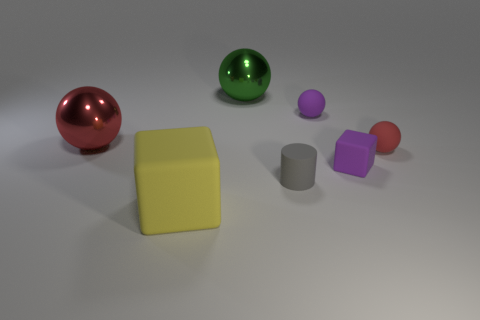There is a ball that is the same color as the tiny rubber block; what size is it? The ball that shares the same vibrant purple hue as the tiny rubber block is medium-sized in comparison to the other items in the image. 